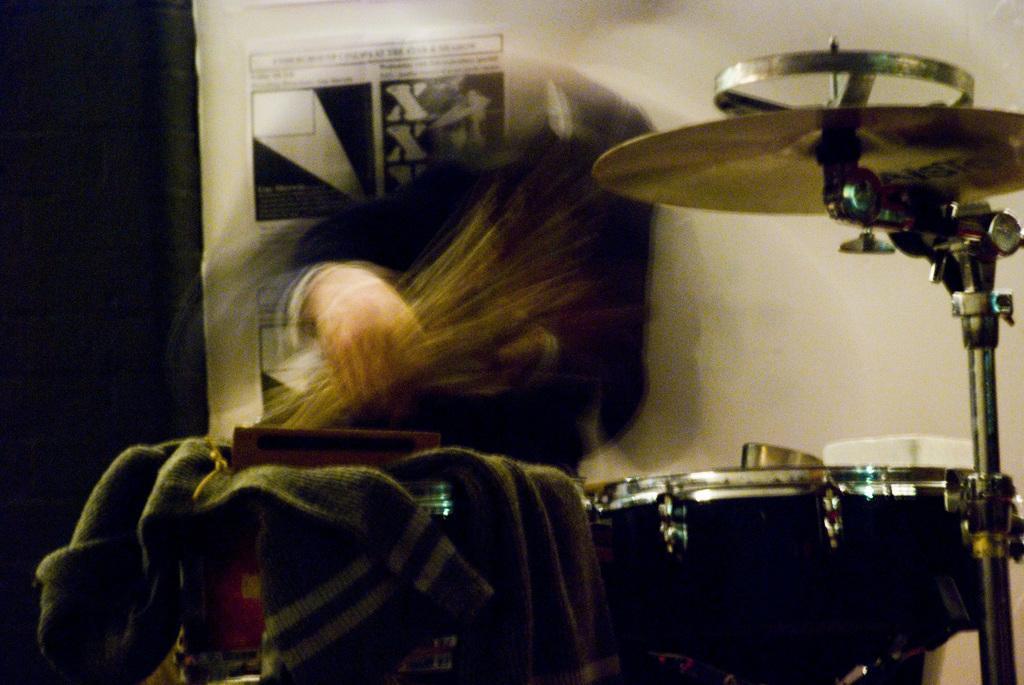In one or two sentences, can you explain what this image depicts? In this image we can see a blur image of a person holding an object, there are musical instruments and clothes and in the background there is a poster with text on the wall. 